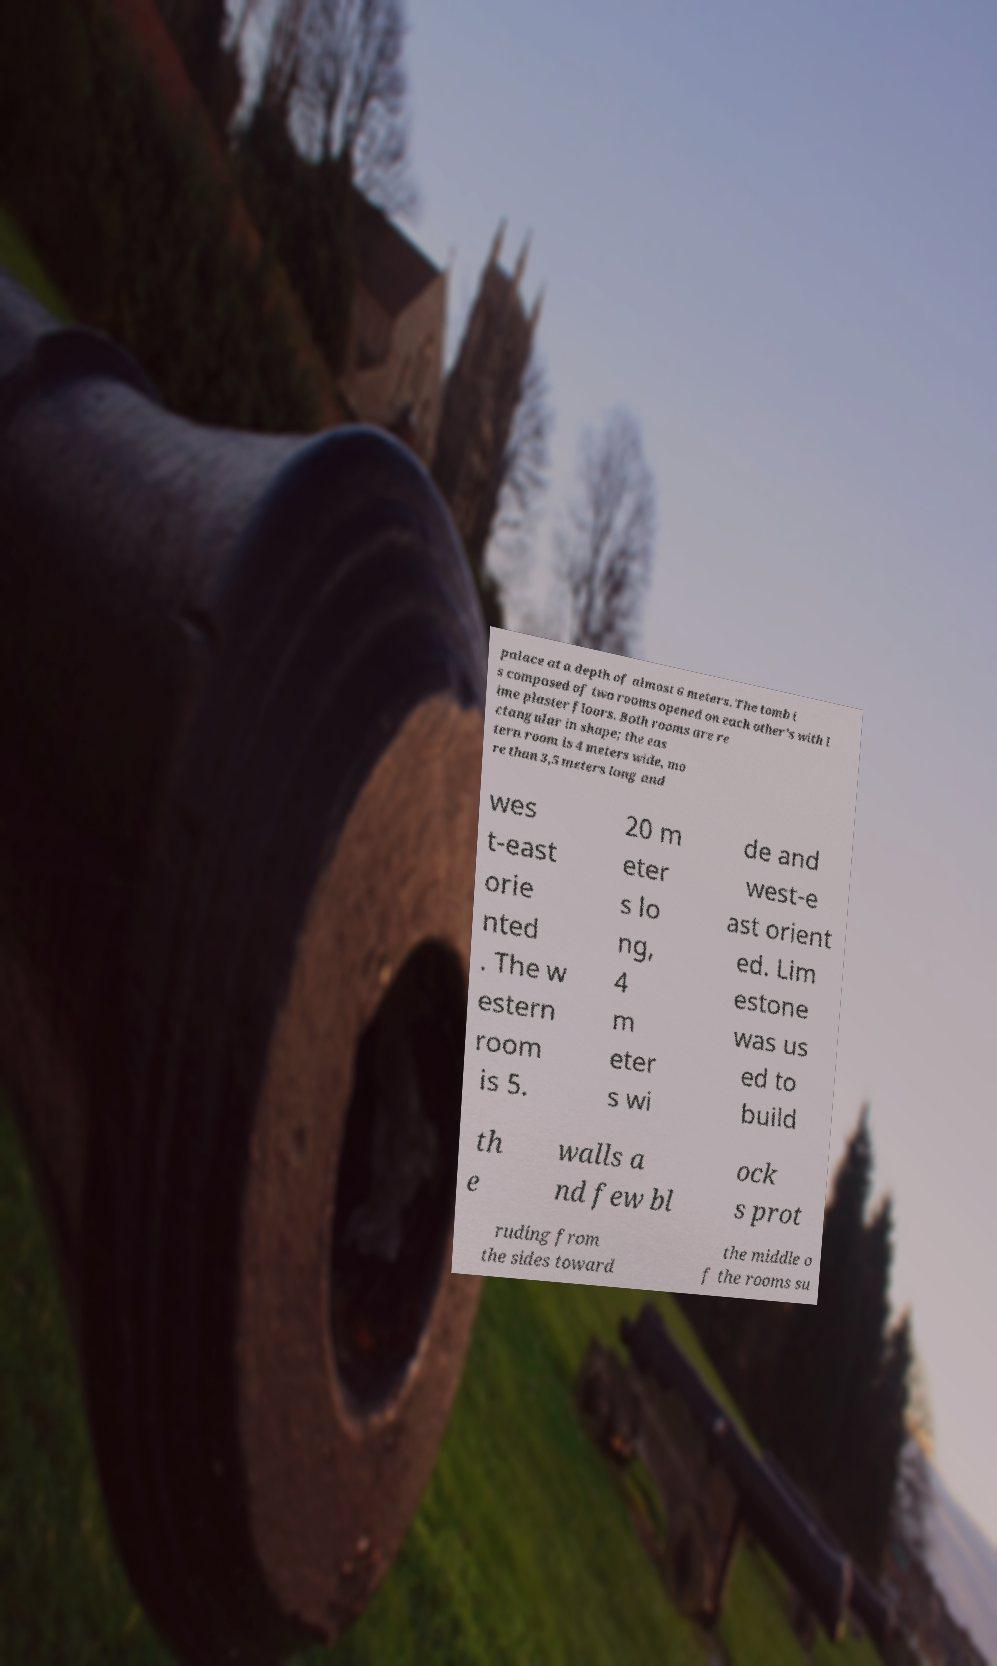Could you assist in decoding the text presented in this image and type it out clearly? palace at a depth of almost 6 meters. The tomb i s composed of two rooms opened on each other's with l ime plaster floors. Both rooms are re ctangular in shape; the eas tern room is 4 meters wide, mo re than 3,5 meters long and wes t-east orie nted . The w estern room is 5. 20 m eter s lo ng, 4 m eter s wi de and west-e ast orient ed. Lim estone was us ed to build th e walls a nd few bl ock s prot ruding from the sides toward the middle o f the rooms su 